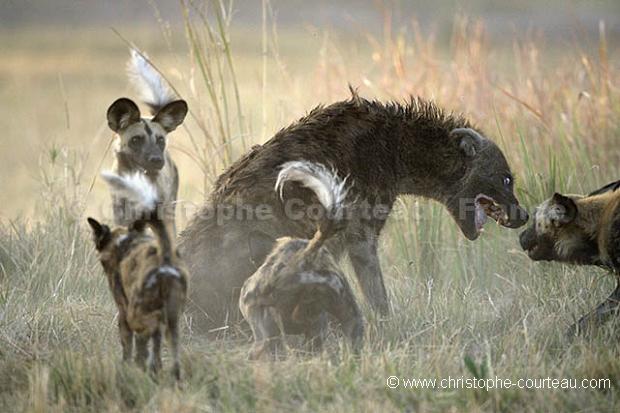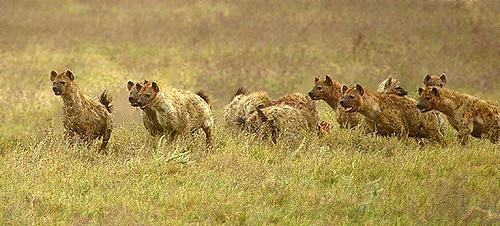The first image is the image on the left, the second image is the image on the right. For the images shown, is this caption "In the image to the left, at least one african_wild_dog faces off against a hyena." true? Answer yes or no. Yes. The first image is the image on the left, the second image is the image on the right. Evaluate the accuracy of this statement regarding the images: "There are 1 or more hyena's attacking another animal.". Is it true? Answer yes or no. Yes. 